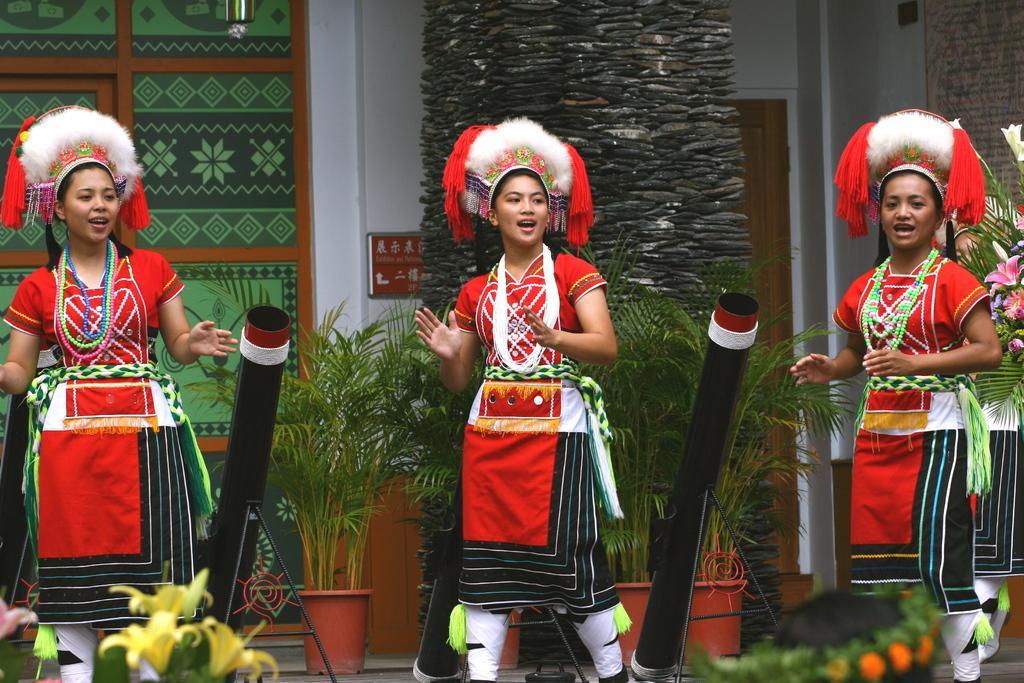Please provide a concise description of this image. In the image there are three women in the foreground, they are wearing different costumes and around them there are plants and other objects, in the background there is a wall and on the right side there is another person. 